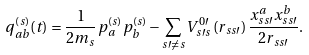<formula> <loc_0><loc_0><loc_500><loc_500>q _ { a b } ^ { ( s ) } ( t ) = \frac { 1 } { 2 m _ { s } } p _ { a } ^ { ( s ) } p _ { b } ^ { ( s ) } - \sum _ { s \prime \neq s } V _ { s \prime s } ^ { 0 \prime } \left ( r _ { s s \prime } \right ) \frac { x _ { s s \prime } ^ { a } x _ { s s \prime } ^ { b } } { 2 r _ { s s \prime } } .</formula> 